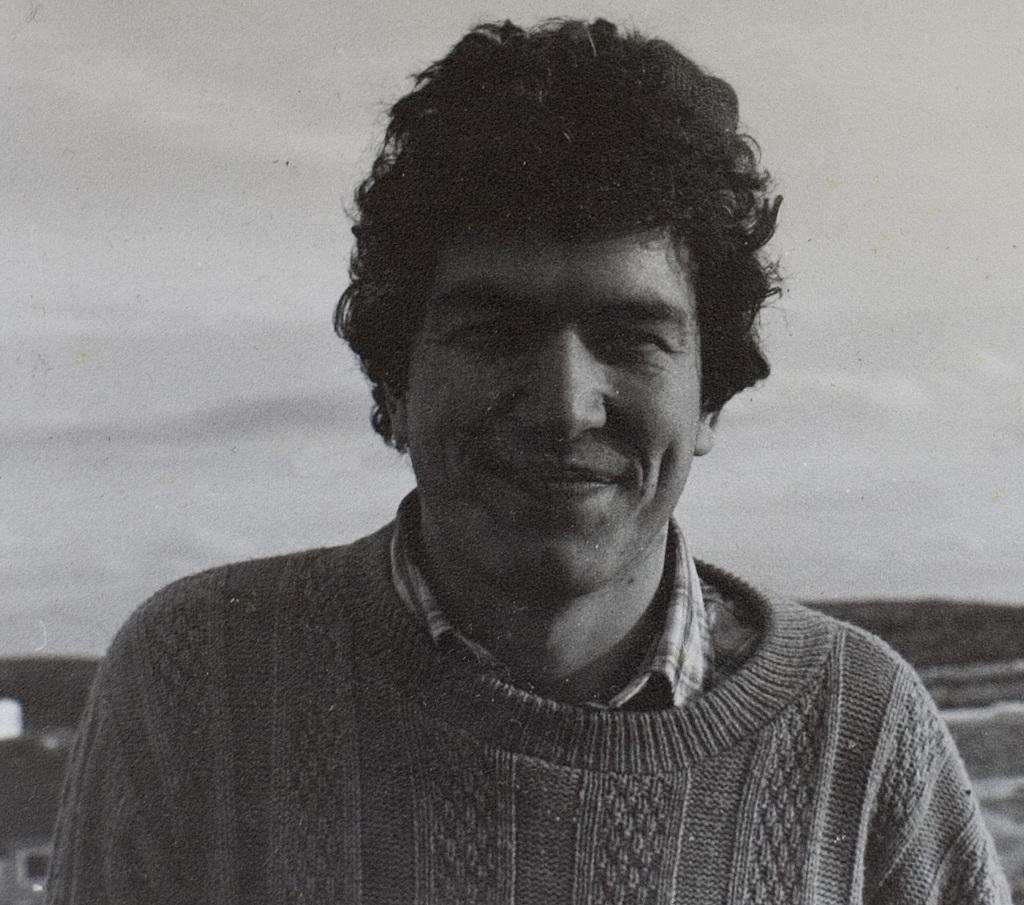Could you give a brief overview of what you see in this image? In this picture we can see a person smiling. 